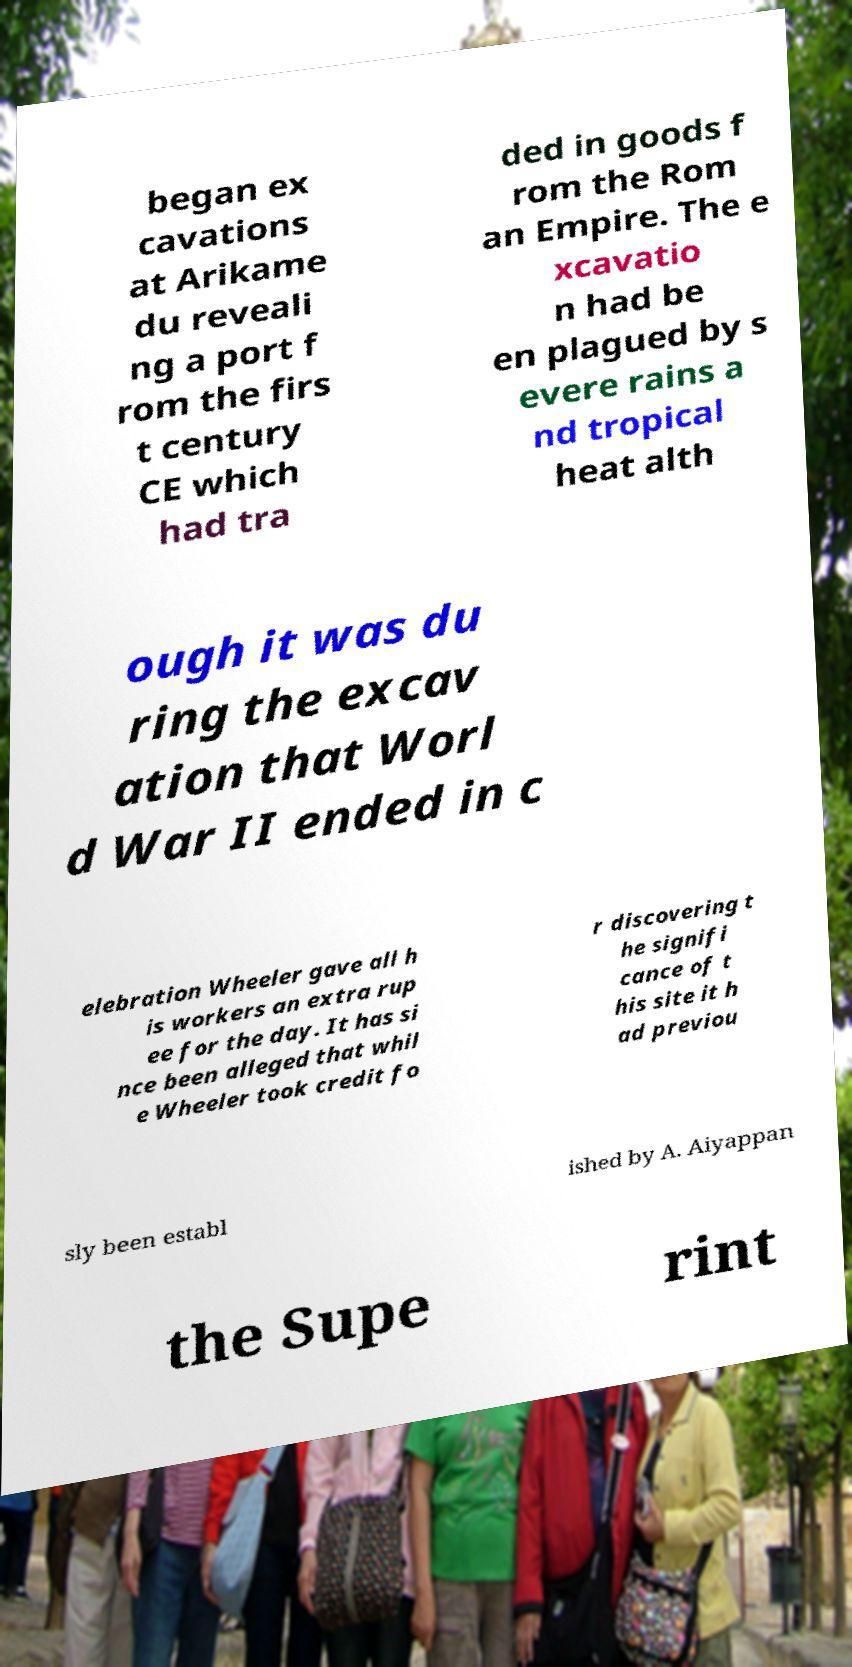Please read and relay the text visible in this image. What does it say? began ex cavations at Arikame du reveali ng a port f rom the firs t century CE which had tra ded in goods f rom the Rom an Empire. The e xcavatio n had be en plagued by s evere rains a nd tropical heat alth ough it was du ring the excav ation that Worl d War II ended in c elebration Wheeler gave all h is workers an extra rup ee for the day. It has si nce been alleged that whil e Wheeler took credit fo r discovering t he signifi cance of t his site it h ad previou sly been establ ished by A. Aiyappan the Supe rint 